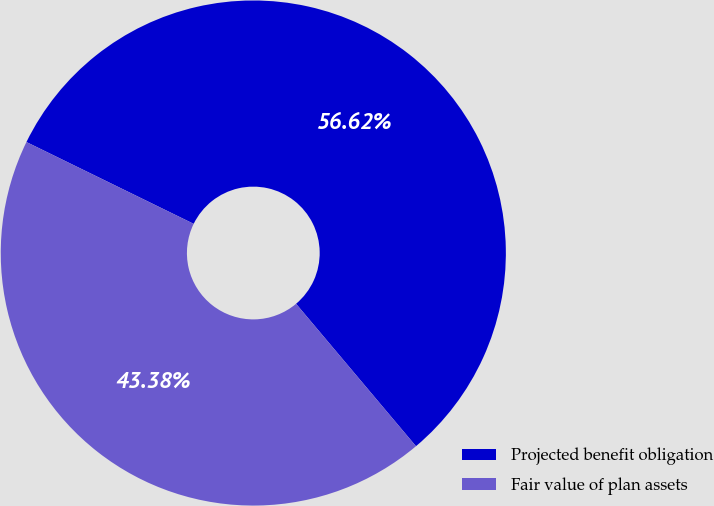<chart> <loc_0><loc_0><loc_500><loc_500><pie_chart><fcel>Projected benefit obligation<fcel>Fair value of plan assets<nl><fcel>56.62%<fcel>43.38%<nl></chart> 